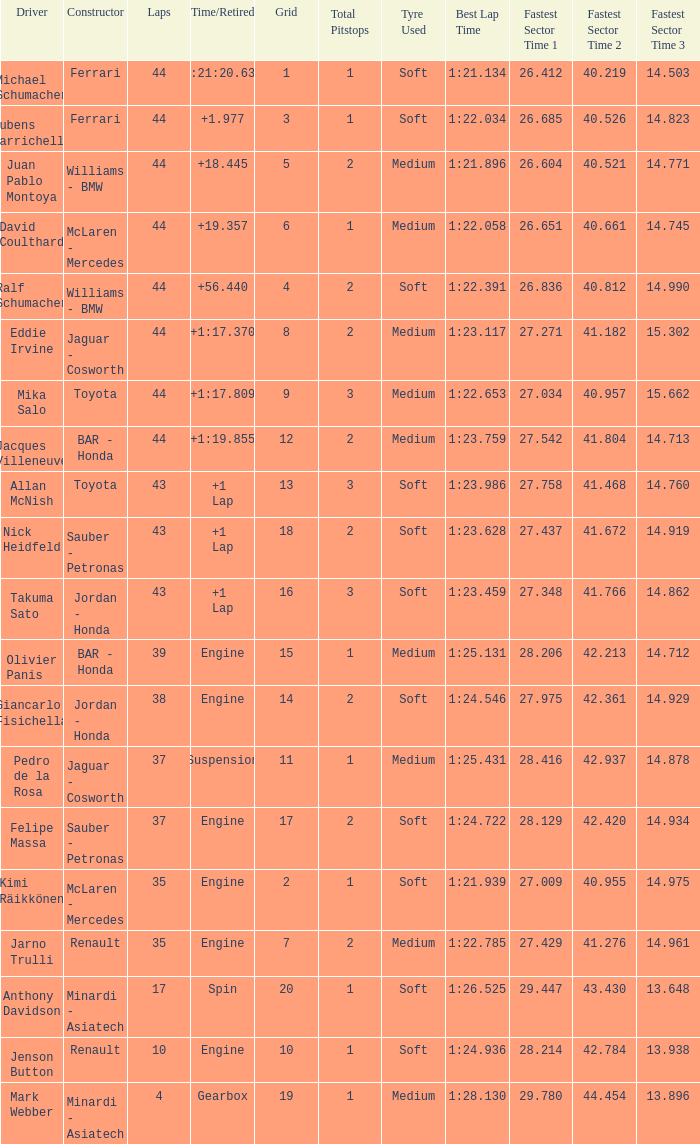What was the time of the driver on grid 3? 1.977. 